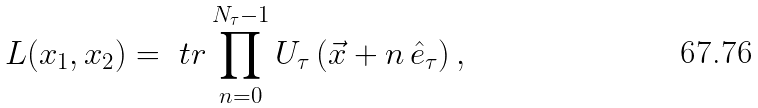<formula> <loc_0><loc_0><loc_500><loc_500>L ( x _ { 1 } , x _ { 2 } ) = \ t r \prod _ { n = 0 } ^ { N _ { \tau } - 1 } U _ { \tau } \left ( \vec { x } + n \, \hat { e } _ { \tau } \right ) ,</formula> 